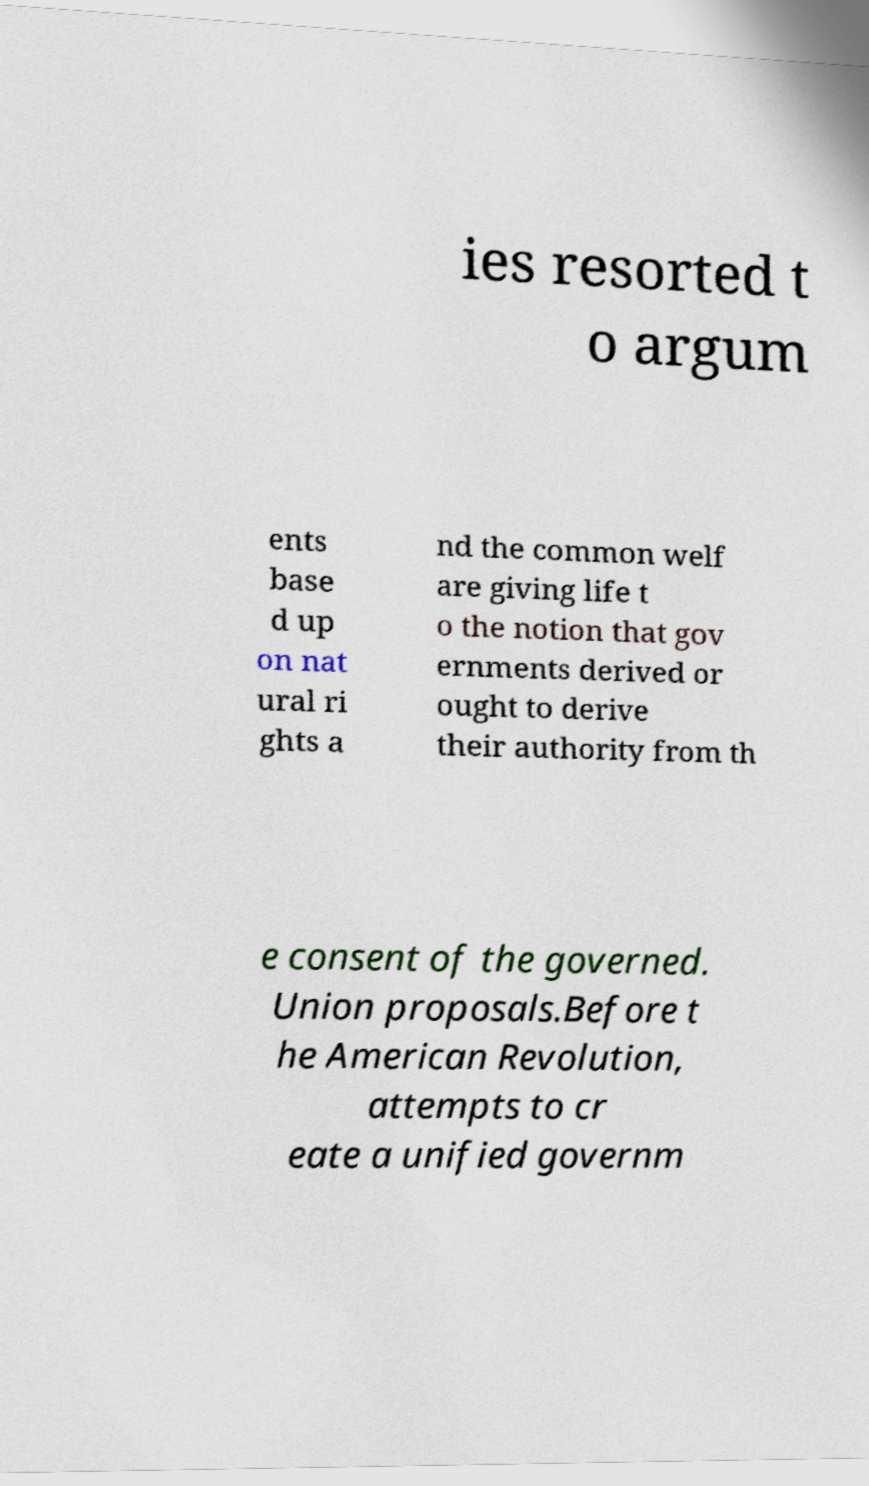Could you assist in decoding the text presented in this image and type it out clearly? ies resorted t o argum ents base d up on nat ural ri ghts a nd the common welf are giving life t o the notion that gov ernments derived or ought to derive their authority from th e consent of the governed. Union proposals.Before t he American Revolution, attempts to cr eate a unified governm 